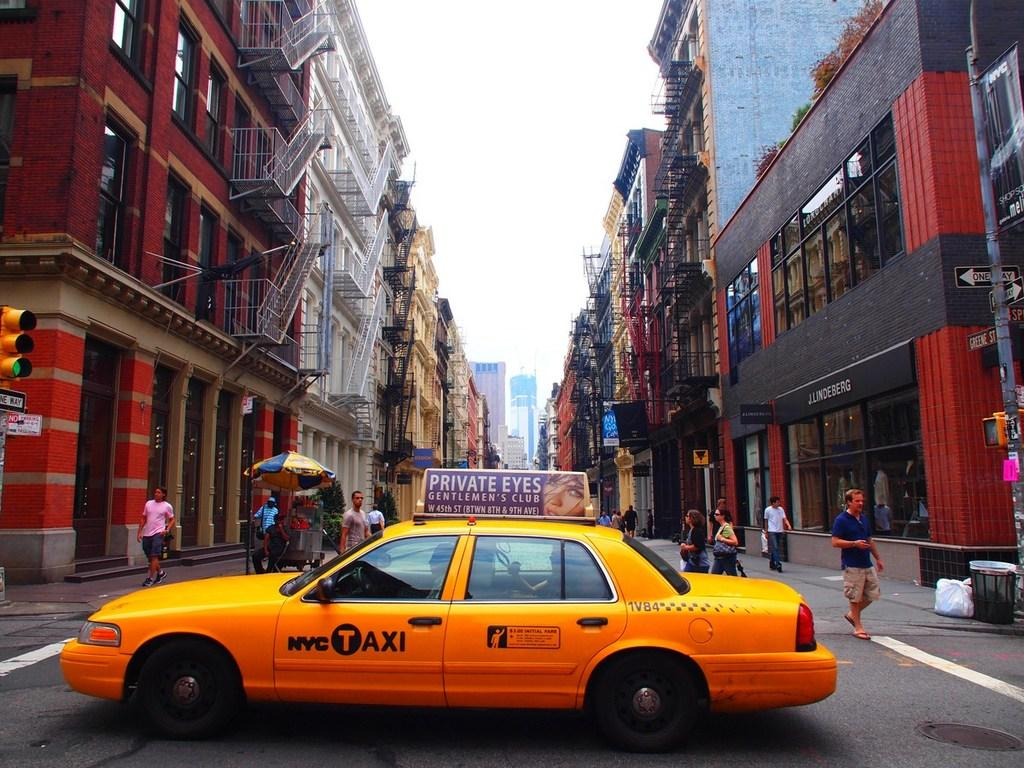What is the color of the car in the middle of the road? The car in the middle of the road is yellow. What are the people in the background doing? The people in the background are walking. What can be seen on either side of the road? There are buildings on either side of the road. What is visible above the scene? The sky is visible above the scene. What type of spoon is being used to stir the celery in the image? There is no spoon or celery present in the image. 